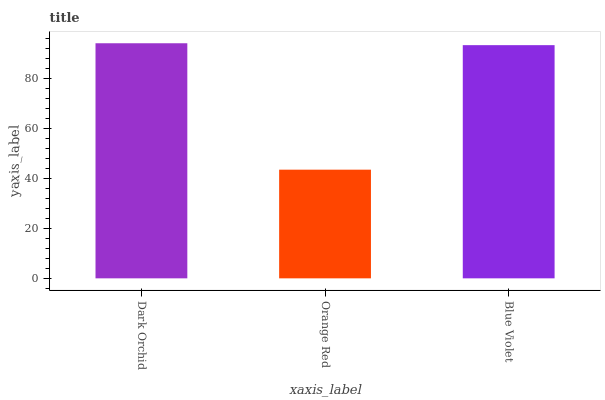Is Orange Red the minimum?
Answer yes or no. Yes. Is Dark Orchid the maximum?
Answer yes or no. Yes. Is Blue Violet the minimum?
Answer yes or no. No. Is Blue Violet the maximum?
Answer yes or no. No. Is Blue Violet greater than Orange Red?
Answer yes or no. Yes. Is Orange Red less than Blue Violet?
Answer yes or no. Yes. Is Orange Red greater than Blue Violet?
Answer yes or no. No. Is Blue Violet less than Orange Red?
Answer yes or no. No. Is Blue Violet the high median?
Answer yes or no. Yes. Is Blue Violet the low median?
Answer yes or no. Yes. Is Orange Red the high median?
Answer yes or no. No. Is Dark Orchid the low median?
Answer yes or no. No. 